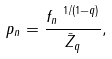<formula> <loc_0><loc_0><loc_500><loc_500>p _ { n } = \frac { f _ { n } ^ { \ 1 / ( 1 - q ) } } { \bar { Z } _ { q } } ,</formula> 